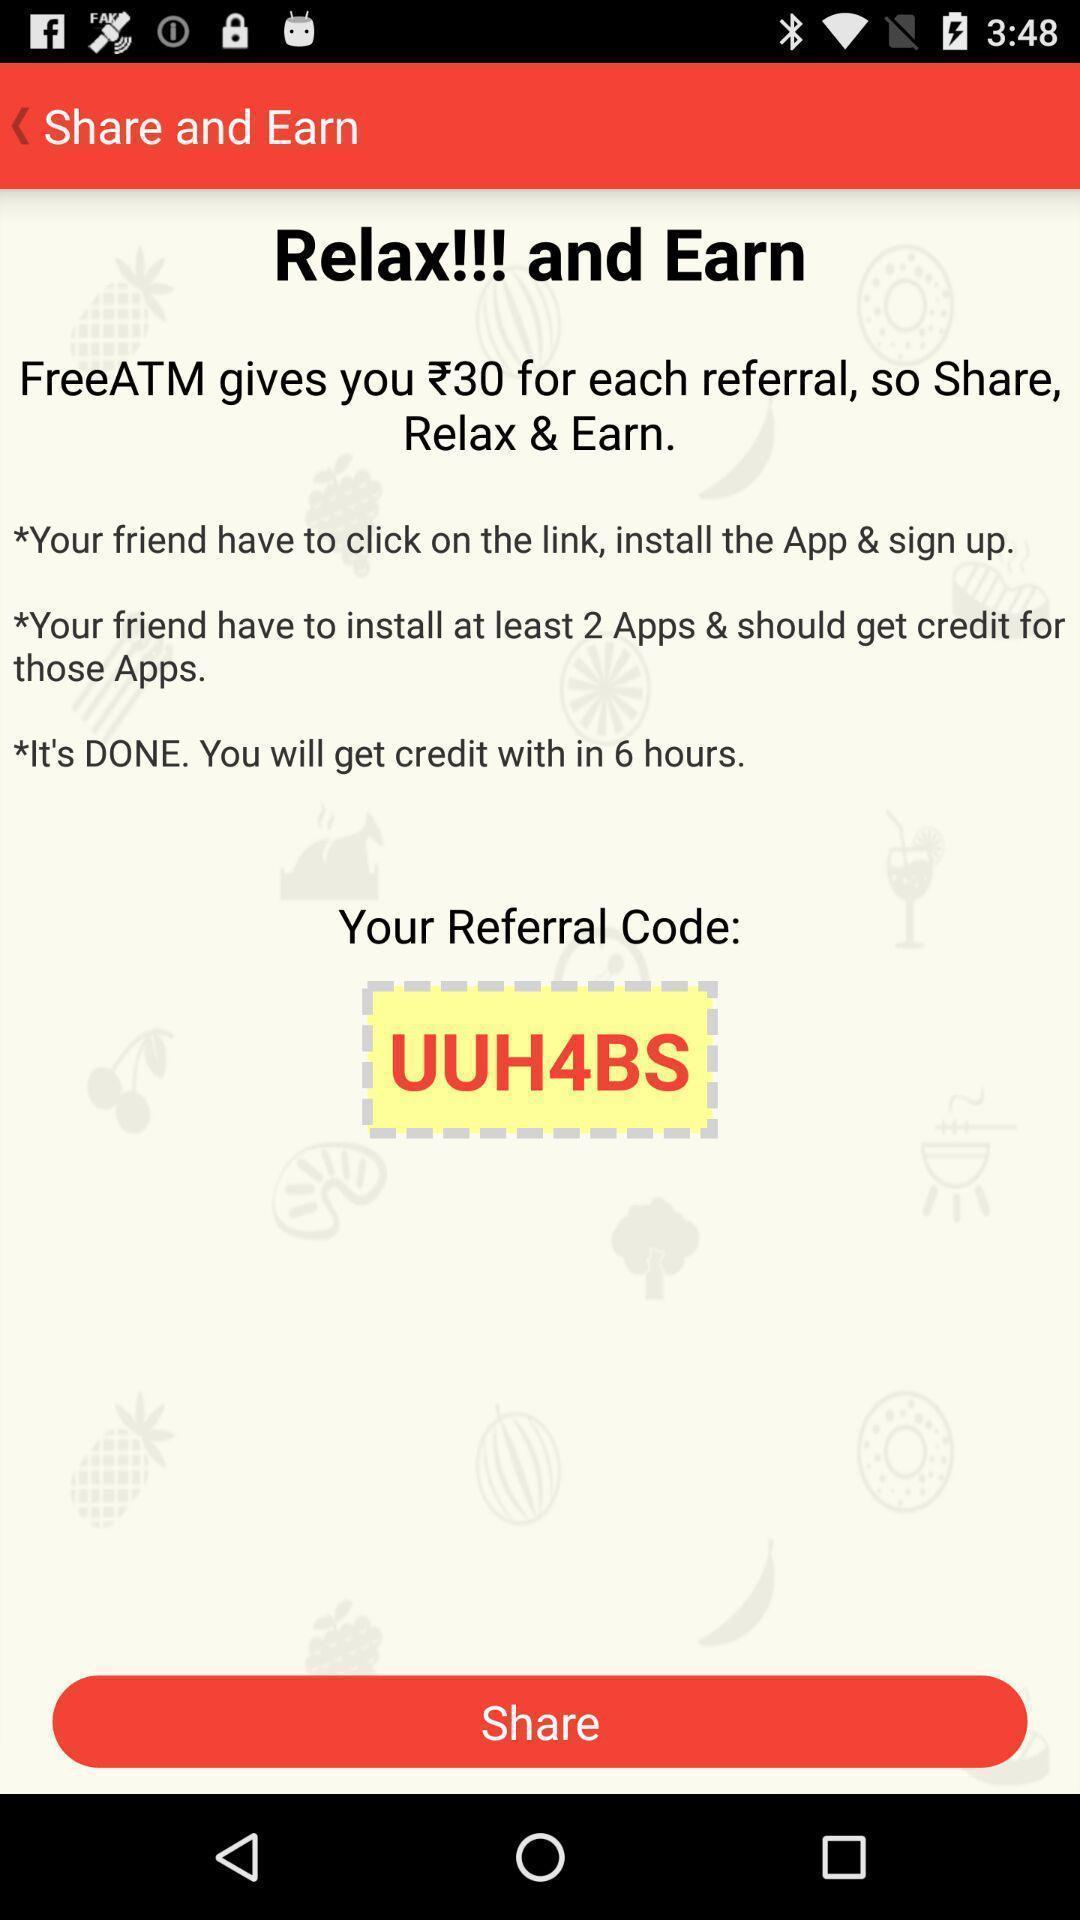Provide a description of this screenshot. Screen shows share and earn page. 